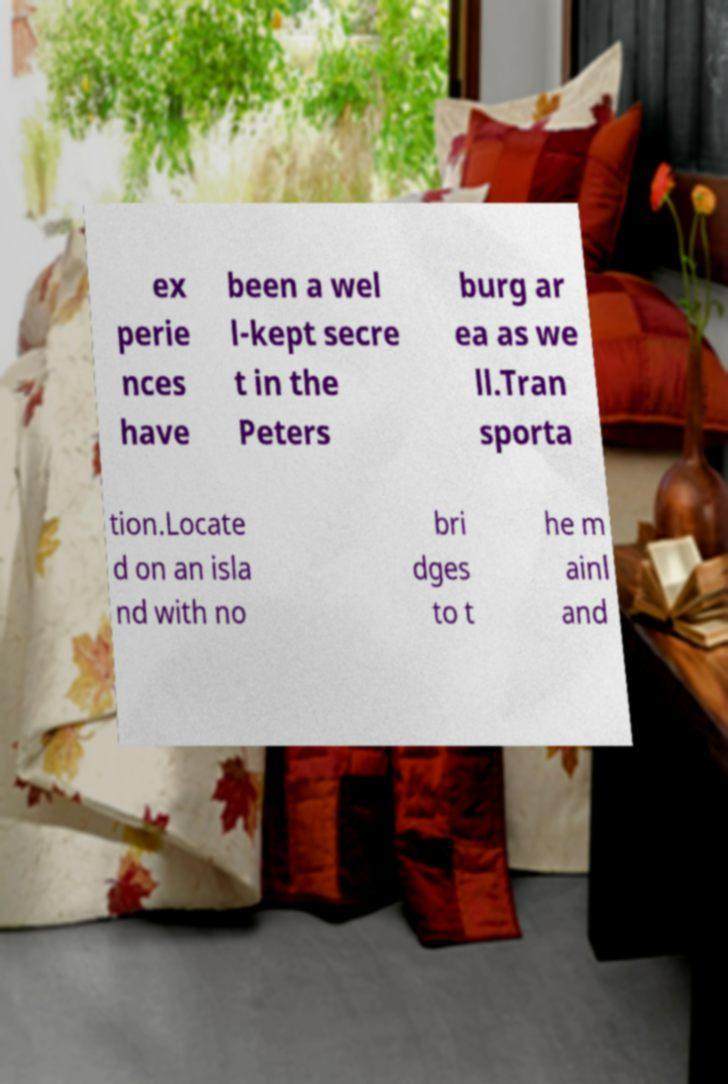Please read and relay the text visible in this image. What does it say? ex perie nces have been a wel l-kept secre t in the Peters burg ar ea as we ll.Tran sporta tion.Locate d on an isla nd with no bri dges to t he m ainl and 